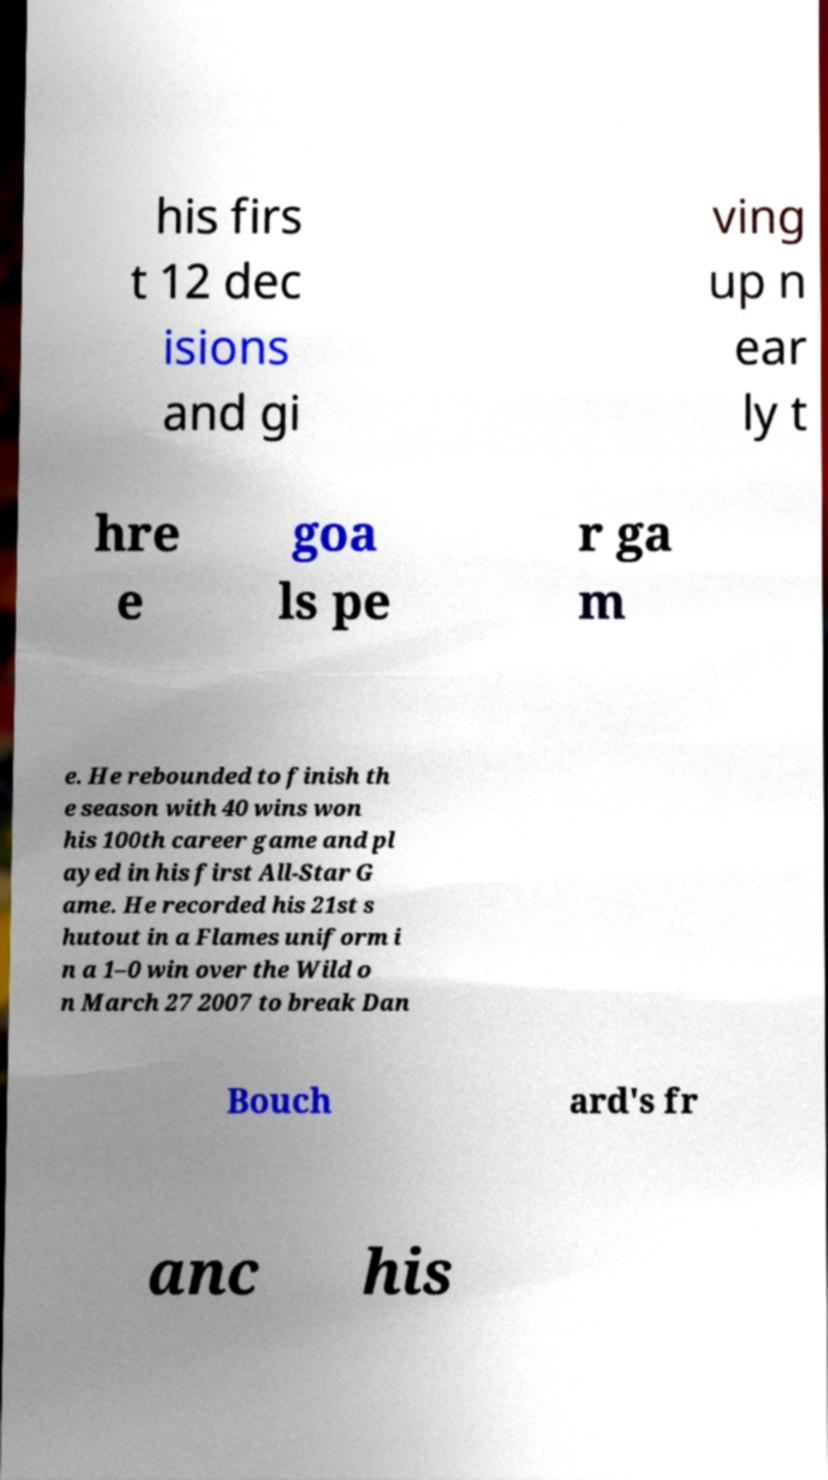For documentation purposes, I need the text within this image transcribed. Could you provide that? his firs t 12 dec isions and gi ving up n ear ly t hre e goa ls pe r ga m e. He rebounded to finish th e season with 40 wins won his 100th career game and pl ayed in his first All-Star G ame. He recorded his 21st s hutout in a Flames uniform i n a 1–0 win over the Wild o n March 27 2007 to break Dan Bouch ard's fr anc his 